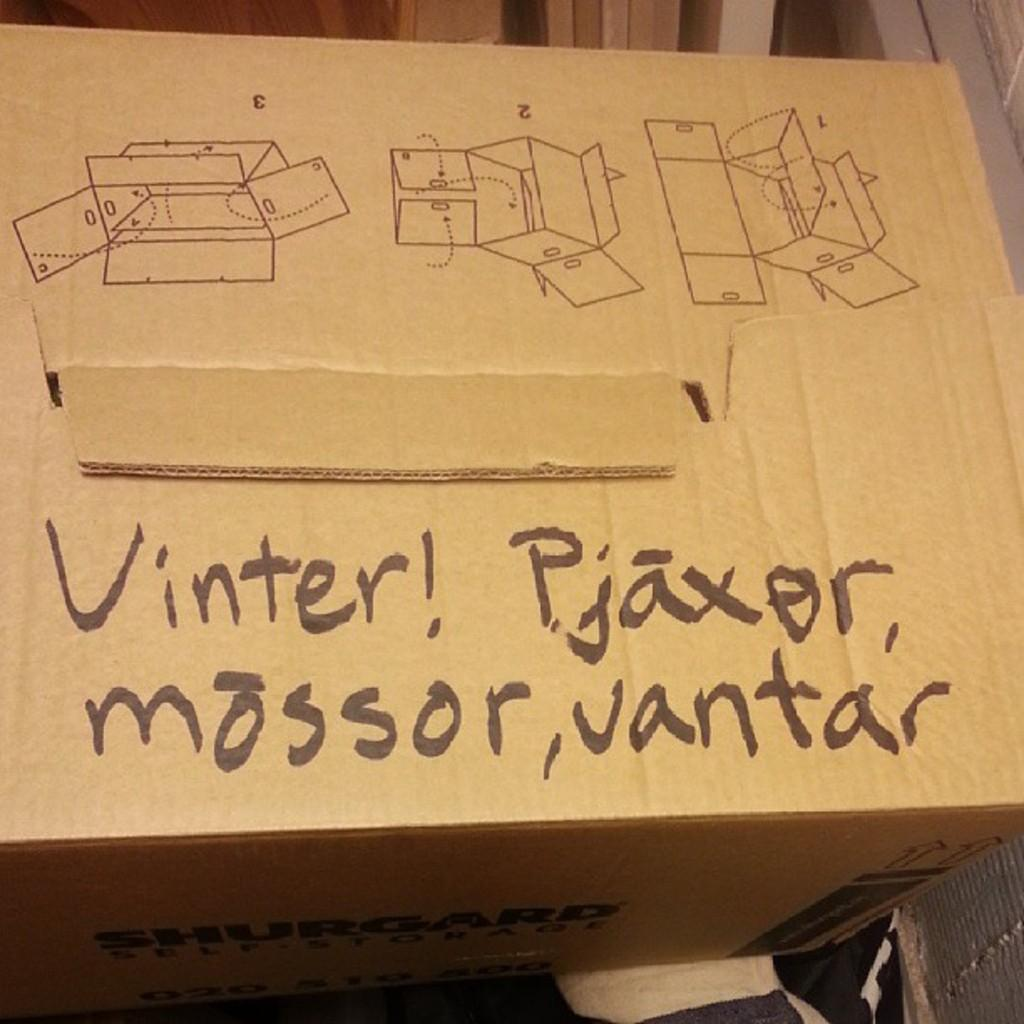<image>
Give a short and clear explanation of the subsequent image. a box that says 'vinter! pjaxor mossor, vantar' in permanent marker 